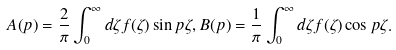Convert formula to latex. <formula><loc_0><loc_0><loc_500><loc_500>A ( p ) = \frac { 2 } { \pi } \int _ { 0 } ^ { \infty } d \zeta f ( \zeta ) \sin p \zeta , B ( p ) = \frac { 1 } { \pi } \int _ { 0 } ^ { \infty } d \zeta f ( \zeta ) \cos p \zeta .</formula> 